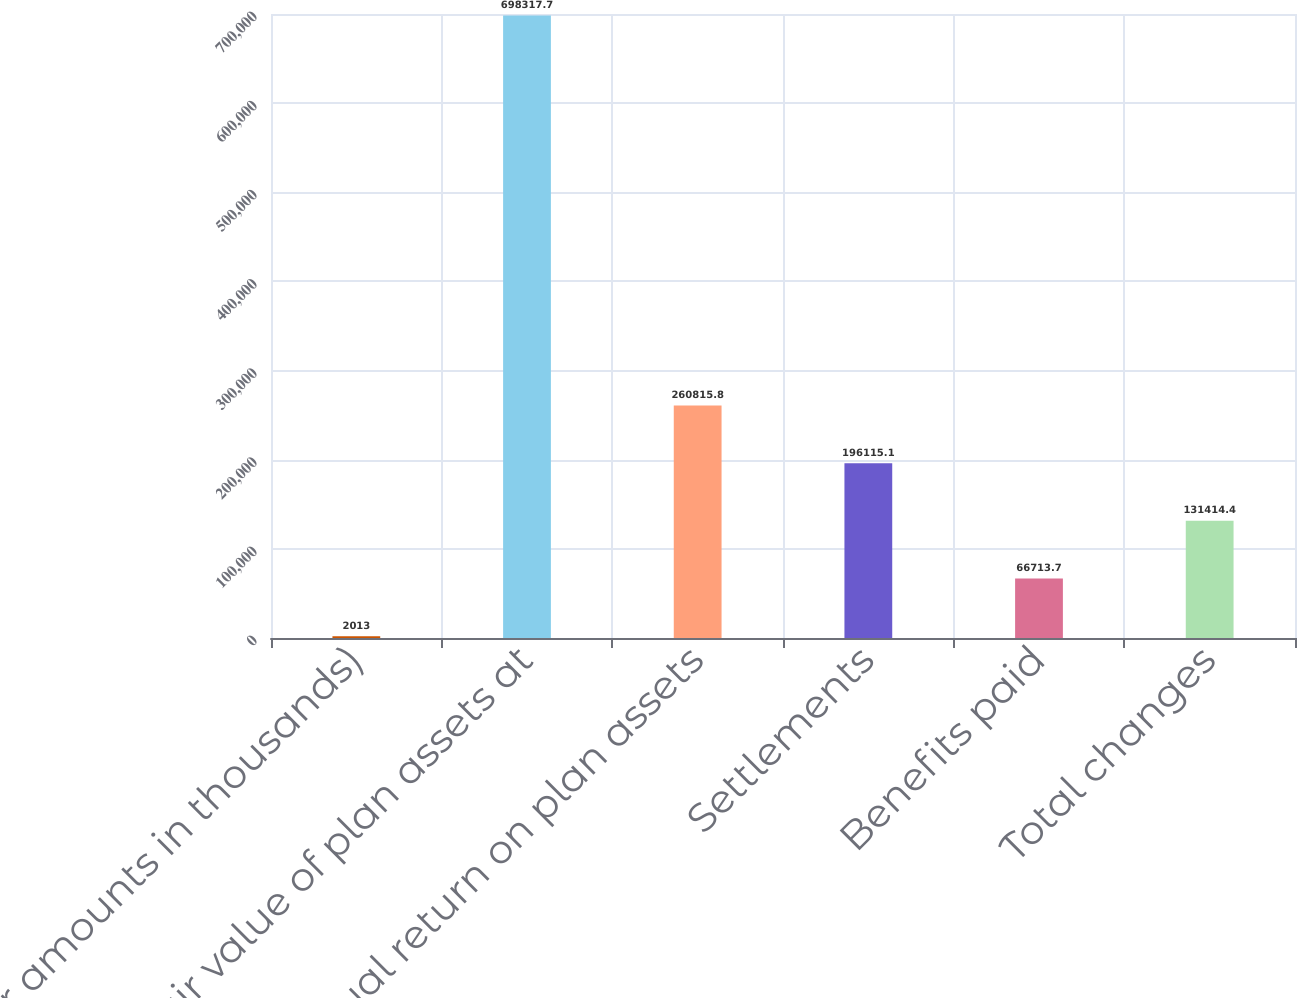Convert chart. <chart><loc_0><loc_0><loc_500><loc_500><bar_chart><fcel>(dollar amounts in thousands)<fcel>Fair value of plan assets at<fcel>Actual return on plan assets<fcel>Settlements<fcel>Benefits paid<fcel>Total changes<nl><fcel>2013<fcel>698318<fcel>260816<fcel>196115<fcel>66713.7<fcel>131414<nl></chart> 